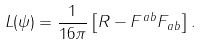<formula> <loc_0><loc_0><loc_500><loc_500>L ( \psi ) = \frac { 1 } { 1 6 \pi } \left [ R - F ^ { a b } F _ { a b } \right ] .</formula> 